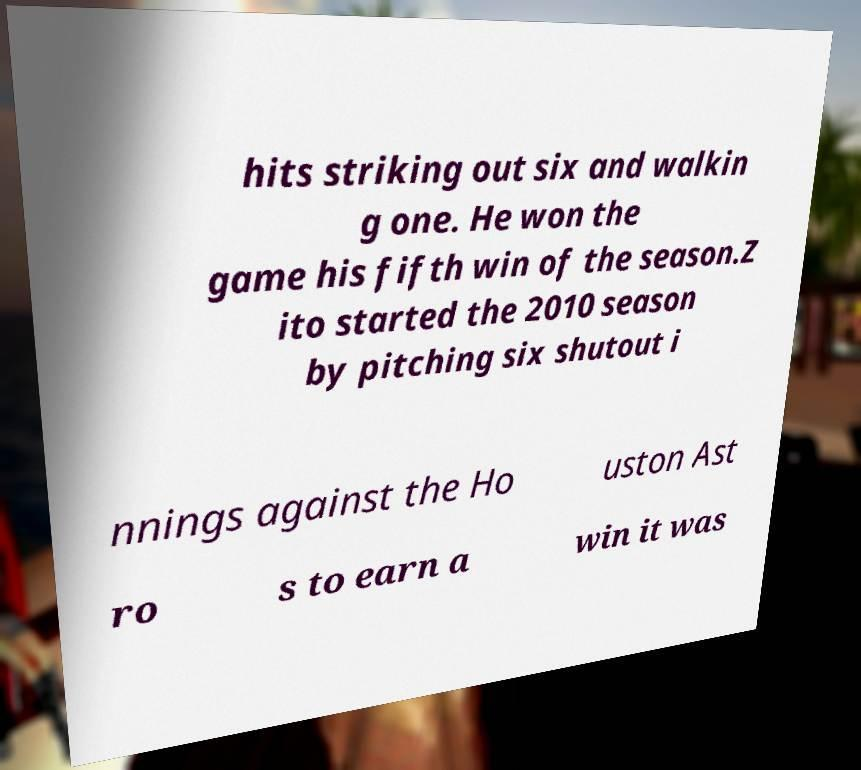I need the written content from this picture converted into text. Can you do that? hits striking out six and walkin g one. He won the game his fifth win of the season.Z ito started the 2010 season by pitching six shutout i nnings against the Ho uston Ast ro s to earn a win it was 